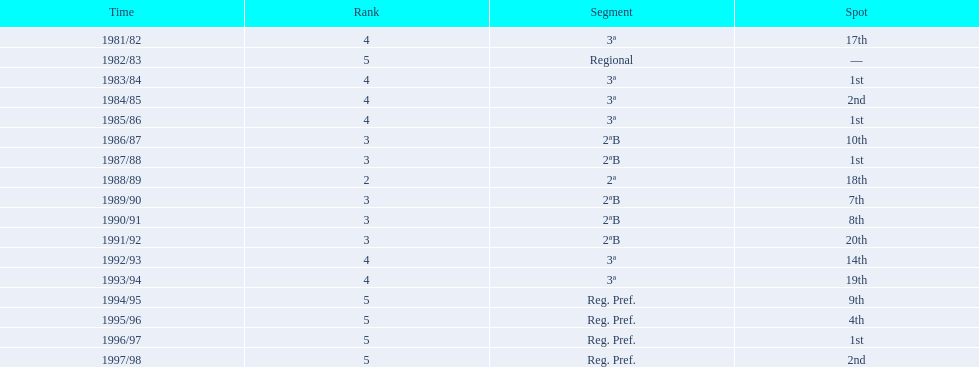What is the lowest place the team has come out? 20th. In what year did they come out in 20th place? 1991/92. 